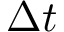Convert formula to latex. <formula><loc_0><loc_0><loc_500><loc_500>\Delta t</formula> 